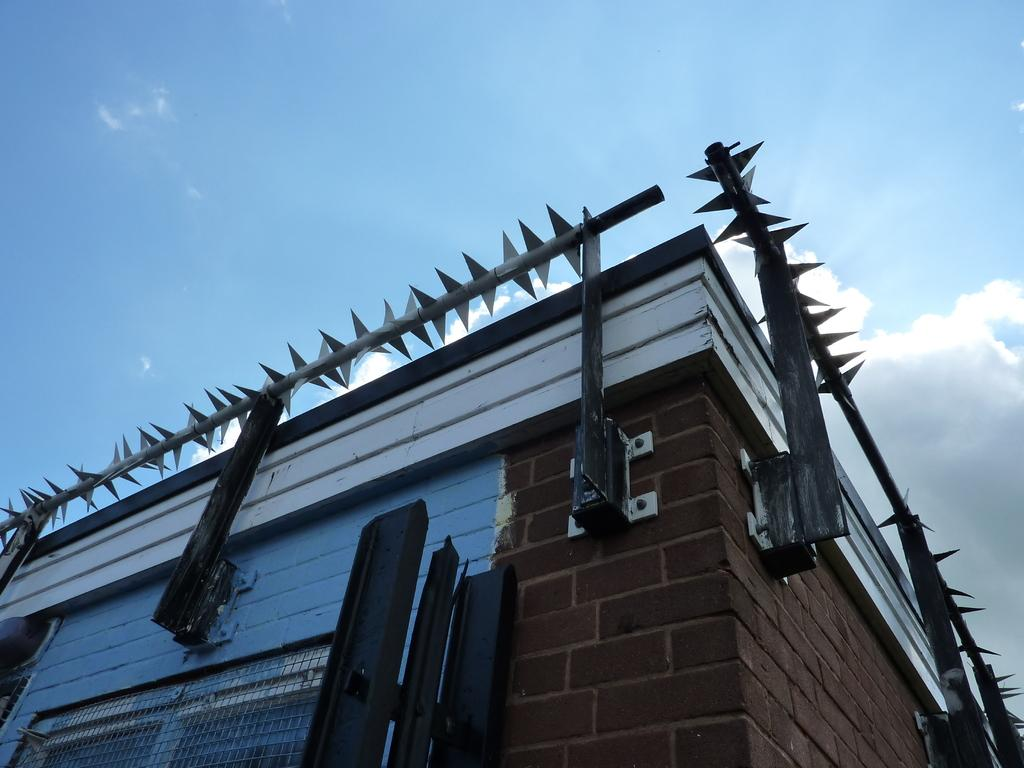What type of structure is present in the image? There is a building in the image. What type of barrier is visible in the image? There is a metal fence in the image. What is the condition of the sky in the image? The sky is cloudy in the image. What type of downtown area can be seen in the image? There is no reference to a downtown area in the image; it only features a building and a metal fence. What type of power source is visible in the image? There is no power source visible in the image. What type of appliance can be seen plugged into the wall in the image? There is no appliance visible in the image. 